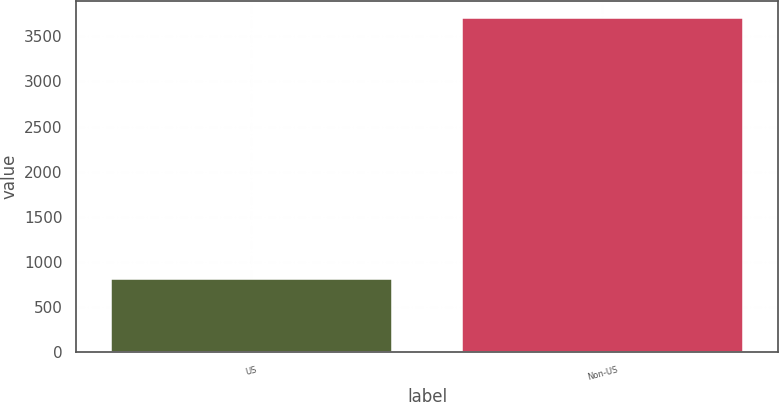Convert chart to OTSL. <chart><loc_0><loc_0><loc_500><loc_500><bar_chart><fcel>US<fcel>Non-US<nl><fcel>809<fcel>3707<nl></chart> 